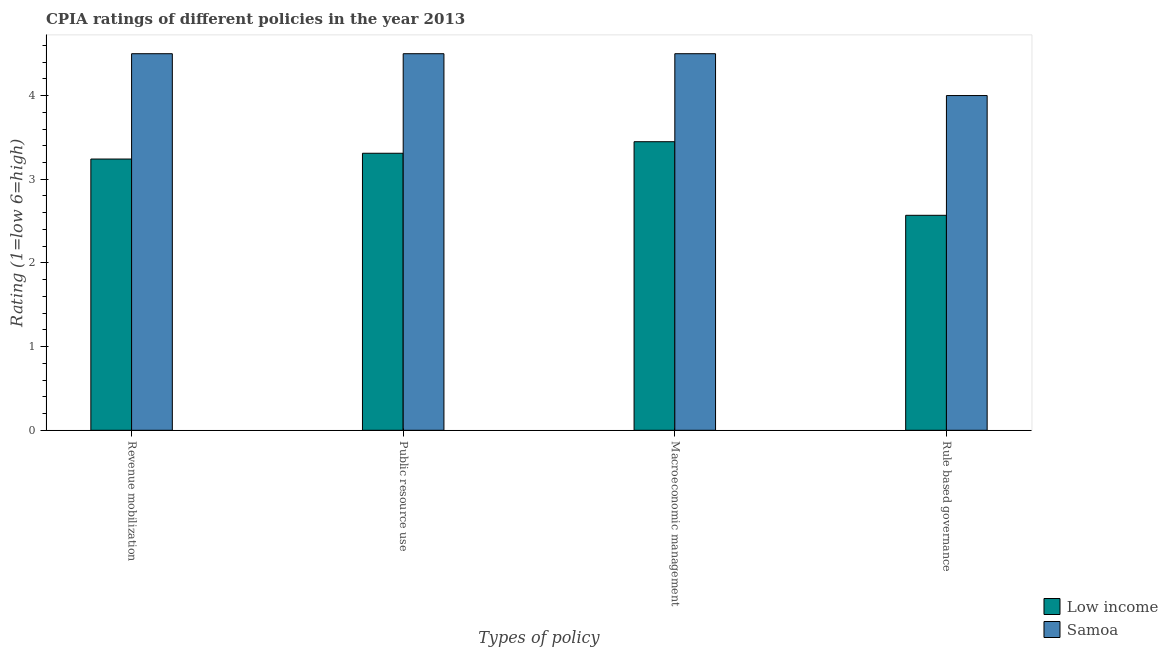How many different coloured bars are there?
Keep it short and to the point. 2. How many groups of bars are there?
Provide a succinct answer. 4. Are the number of bars per tick equal to the number of legend labels?
Ensure brevity in your answer.  Yes. Are the number of bars on each tick of the X-axis equal?
Make the answer very short. Yes. What is the label of the 4th group of bars from the left?
Your answer should be very brief. Rule based governance. Across all countries, what is the minimum cpia rating of macroeconomic management?
Offer a terse response. 3.45. In which country was the cpia rating of public resource use maximum?
Offer a terse response. Samoa. What is the total cpia rating of macroeconomic management in the graph?
Your answer should be very brief. 7.95. What is the difference between the cpia rating of public resource use in Samoa and that in Low income?
Ensure brevity in your answer.  1.19. What is the difference between the cpia rating of public resource use in Low income and the cpia rating of revenue mobilization in Samoa?
Offer a very short reply. -1.19. What is the average cpia rating of macroeconomic management per country?
Make the answer very short. 3.97. What is the difference between the cpia rating of public resource use and cpia rating of rule based governance in Low income?
Provide a succinct answer. 0.74. In how many countries, is the cpia rating of revenue mobilization greater than 1.4 ?
Your answer should be very brief. 2. What is the ratio of the cpia rating of rule based governance in Low income to that in Samoa?
Give a very brief answer. 0.64. What is the difference between the highest and the second highest cpia rating of public resource use?
Your response must be concise. 1.19. What is the difference between the highest and the lowest cpia rating of revenue mobilization?
Make the answer very short. 1.26. In how many countries, is the cpia rating of public resource use greater than the average cpia rating of public resource use taken over all countries?
Your answer should be very brief. 1. What does the 2nd bar from the right in Rule based governance represents?
Your answer should be compact. Low income. Is it the case that in every country, the sum of the cpia rating of revenue mobilization and cpia rating of public resource use is greater than the cpia rating of macroeconomic management?
Ensure brevity in your answer.  Yes. How many bars are there?
Provide a short and direct response. 8. What is the difference between two consecutive major ticks on the Y-axis?
Make the answer very short. 1. Are the values on the major ticks of Y-axis written in scientific E-notation?
Your response must be concise. No. Where does the legend appear in the graph?
Offer a very short reply. Bottom right. How many legend labels are there?
Your response must be concise. 2. What is the title of the graph?
Make the answer very short. CPIA ratings of different policies in the year 2013. What is the label or title of the X-axis?
Provide a short and direct response. Types of policy. What is the label or title of the Y-axis?
Your answer should be compact. Rating (1=low 6=high). What is the Rating (1=low 6=high) in Low income in Revenue mobilization?
Provide a short and direct response. 3.24. What is the Rating (1=low 6=high) of Samoa in Revenue mobilization?
Offer a terse response. 4.5. What is the Rating (1=low 6=high) in Low income in Public resource use?
Provide a succinct answer. 3.31. What is the Rating (1=low 6=high) in Low income in Macroeconomic management?
Your response must be concise. 3.45. What is the Rating (1=low 6=high) of Samoa in Macroeconomic management?
Ensure brevity in your answer.  4.5. What is the Rating (1=low 6=high) in Low income in Rule based governance?
Offer a very short reply. 2.57. Across all Types of policy, what is the maximum Rating (1=low 6=high) in Low income?
Give a very brief answer. 3.45. Across all Types of policy, what is the minimum Rating (1=low 6=high) of Low income?
Make the answer very short. 2.57. What is the total Rating (1=low 6=high) in Low income in the graph?
Make the answer very short. 12.57. What is the difference between the Rating (1=low 6=high) in Low income in Revenue mobilization and that in Public resource use?
Your answer should be compact. -0.07. What is the difference between the Rating (1=low 6=high) in Samoa in Revenue mobilization and that in Public resource use?
Offer a terse response. 0. What is the difference between the Rating (1=low 6=high) in Low income in Revenue mobilization and that in Macroeconomic management?
Your answer should be very brief. -0.21. What is the difference between the Rating (1=low 6=high) of Low income in Revenue mobilization and that in Rule based governance?
Offer a terse response. 0.67. What is the difference between the Rating (1=low 6=high) in Samoa in Revenue mobilization and that in Rule based governance?
Provide a succinct answer. 0.5. What is the difference between the Rating (1=low 6=high) of Low income in Public resource use and that in Macroeconomic management?
Provide a short and direct response. -0.14. What is the difference between the Rating (1=low 6=high) of Low income in Public resource use and that in Rule based governance?
Offer a very short reply. 0.74. What is the difference between the Rating (1=low 6=high) of Samoa in Public resource use and that in Rule based governance?
Make the answer very short. 0.5. What is the difference between the Rating (1=low 6=high) of Low income in Macroeconomic management and that in Rule based governance?
Make the answer very short. 0.88. What is the difference between the Rating (1=low 6=high) of Samoa in Macroeconomic management and that in Rule based governance?
Your answer should be very brief. 0.5. What is the difference between the Rating (1=low 6=high) in Low income in Revenue mobilization and the Rating (1=low 6=high) in Samoa in Public resource use?
Provide a succinct answer. -1.26. What is the difference between the Rating (1=low 6=high) in Low income in Revenue mobilization and the Rating (1=low 6=high) in Samoa in Macroeconomic management?
Provide a succinct answer. -1.26. What is the difference between the Rating (1=low 6=high) of Low income in Revenue mobilization and the Rating (1=low 6=high) of Samoa in Rule based governance?
Ensure brevity in your answer.  -0.76. What is the difference between the Rating (1=low 6=high) in Low income in Public resource use and the Rating (1=low 6=high) in Samoa in Macroeconomic management?
Give a very brief answer. -1.19. What is the difference between the Rating (1=low 6=high) in Low income in Public resource use and the Rating (1=low 6=high) in Samoa in Rule based governance?
Give a very brief answer. -0.69. What is the difference between the Rating (1=low 6=high) in Low income in Macroeconomic management and the Rating (1=low 6=high) in Samoa in Rule based governance?
Make the answer very short. -0.55. What is the average Rating (1=low 6=high) in Low income per Types of policy?
Make the answer very short. 3.14. What is the average Rating (1=low 6=high) of Samoa per Types of policy?
Ensure brevity in your answer.  4.38. What is the difference between the Rating (1=low 6=high) in Low income and Rating (1=low 6=high) in Samoa in Revenue mobilization?
Provide a short and direct response. -1.26. What is the difference between the Rating (1=low 6=high) of Low income and Rating (1=low 6=high) of Samoa in Public resource use?
Make the answer very short. -1.19. What is the difference between the Rating (1=low 6=high) in Low income and Rating (1=low 6=high) in Samoa in Macroeconomic management?
Your response must be concise. -1.05. What is the difference between the Rating (1=low 6=high) in Low income and Rating (1=low 6=high) in Samoa in Rule based governance?
Offer a terse response. -1.43. What is the ratio of the Rating (1=low 6=high) in Low income in Revenue mobilization to that in Public resource use?
Your response must be concise. 0.98. What is the ratio of the Rating (1=low 6=high) of Low income in Revenue mobilization to that in Rule based governance?
Keep it short and to the point. 1.26. What is the ratio of the Rating (1=low 6=high) of Samoa in Revenue mobilization to that in Rule based governance?
Your response must be concise. 1.12. What is the ratio of the Rating (1=low 6=high) of Low income in Public resource use to that in Macroeconomic management?
Keep it short and to the point. 0.96. What is the ratio of the Rating (1=low 6=high) of Low income in Public resource use to that in Rule based governance?
Your answer should be compact. 1.29. What is the ratio of the Rating (1=low 6=high) in Samoa in Public resource use to that in Rule based governance?
Your answer should be very brief. 1.12. What is the ratio of the Rating (1=low 6=high) of Low income in Macroeconomic management to that in Rule based governance?
Offer a very short reply. 1.34. What is the ratio of the Rating (1=low 6=high) in Samoa in Macroeconomic management to that in Rule based governance?
Your response must be concise. 1.12. What is the difference between the highest and the second highest Rating (1=low 6=high) in Low income?
Offer a terse response. 0.14. What is the difference between the highest and the lowest Rating (1=low 6=high) in Low income?
Provide a succinct answer. 0.88. What is the difference between the highest and the lowest Rating (1=low 6=high) in Samoa?
Offer a terse response. 0.5. 